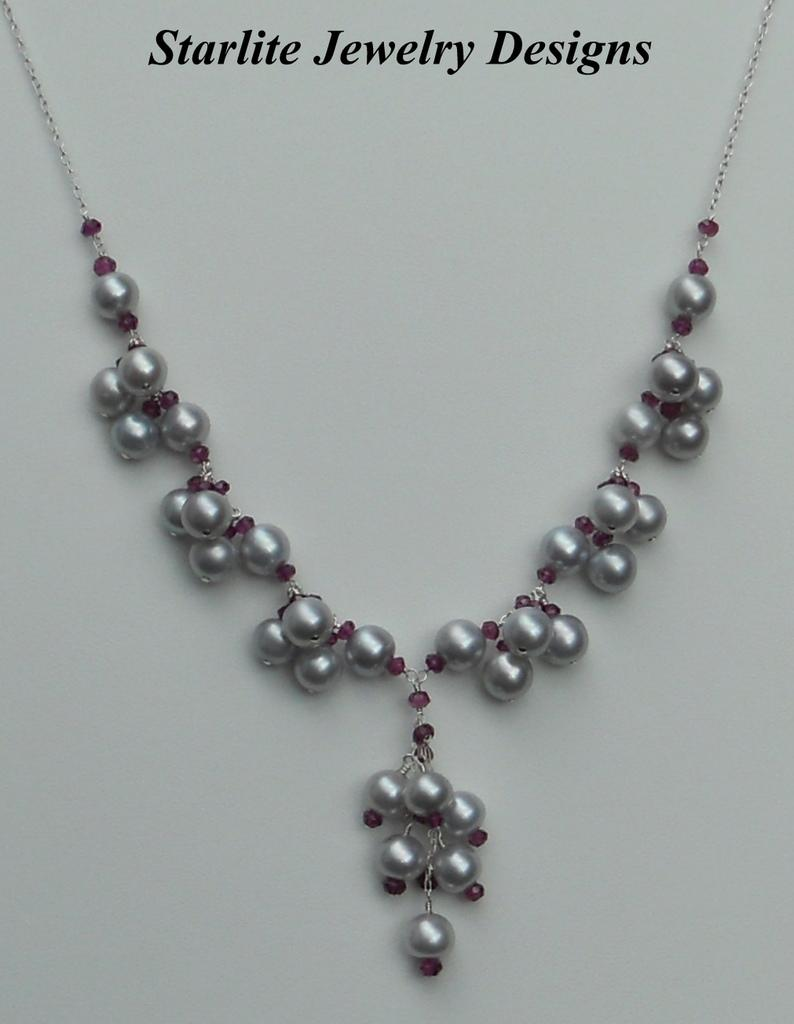What object can be seen in the image? There is an ornament in the image. What else is present at the top of the image? There is text at the top of the image. What type of loaf is being prepared in the image? There is no loaf present in the image; it only features an ornament and text. What authority is depicted in the image? There is no authority depicted in the image; it only features an ornament and text. 